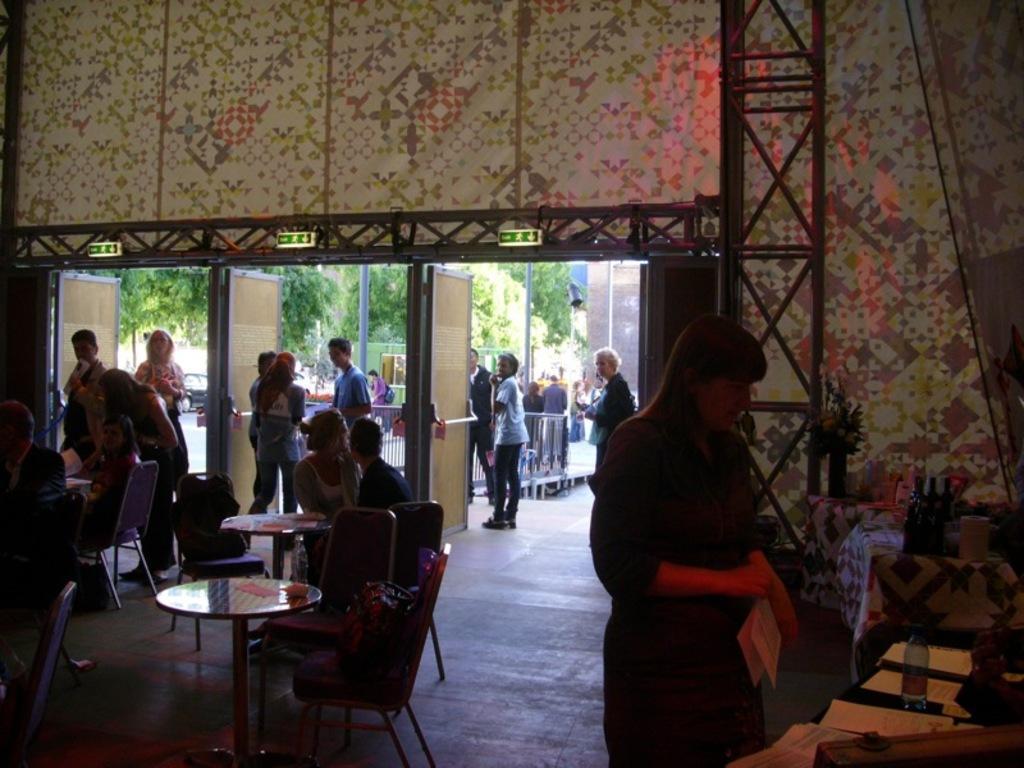Can you describe this image briefly? Some people are entering and exiting at a gate in a restaurant. 